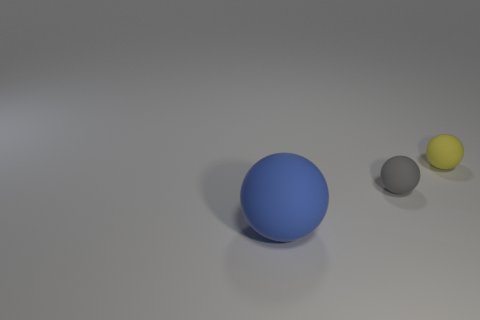Add 2 tiny cyan rubber balls. How many objects exist? 5 Subtract all matte objects. Subtract all purple balls. How many objects are left? 0 Add 3 big blue rubber things. How many big blue rubber things are left? 4 Add 3 large blue things. How many large blue things exist? 4 Subtract 0 purple cubes. How many objects are left? 3 